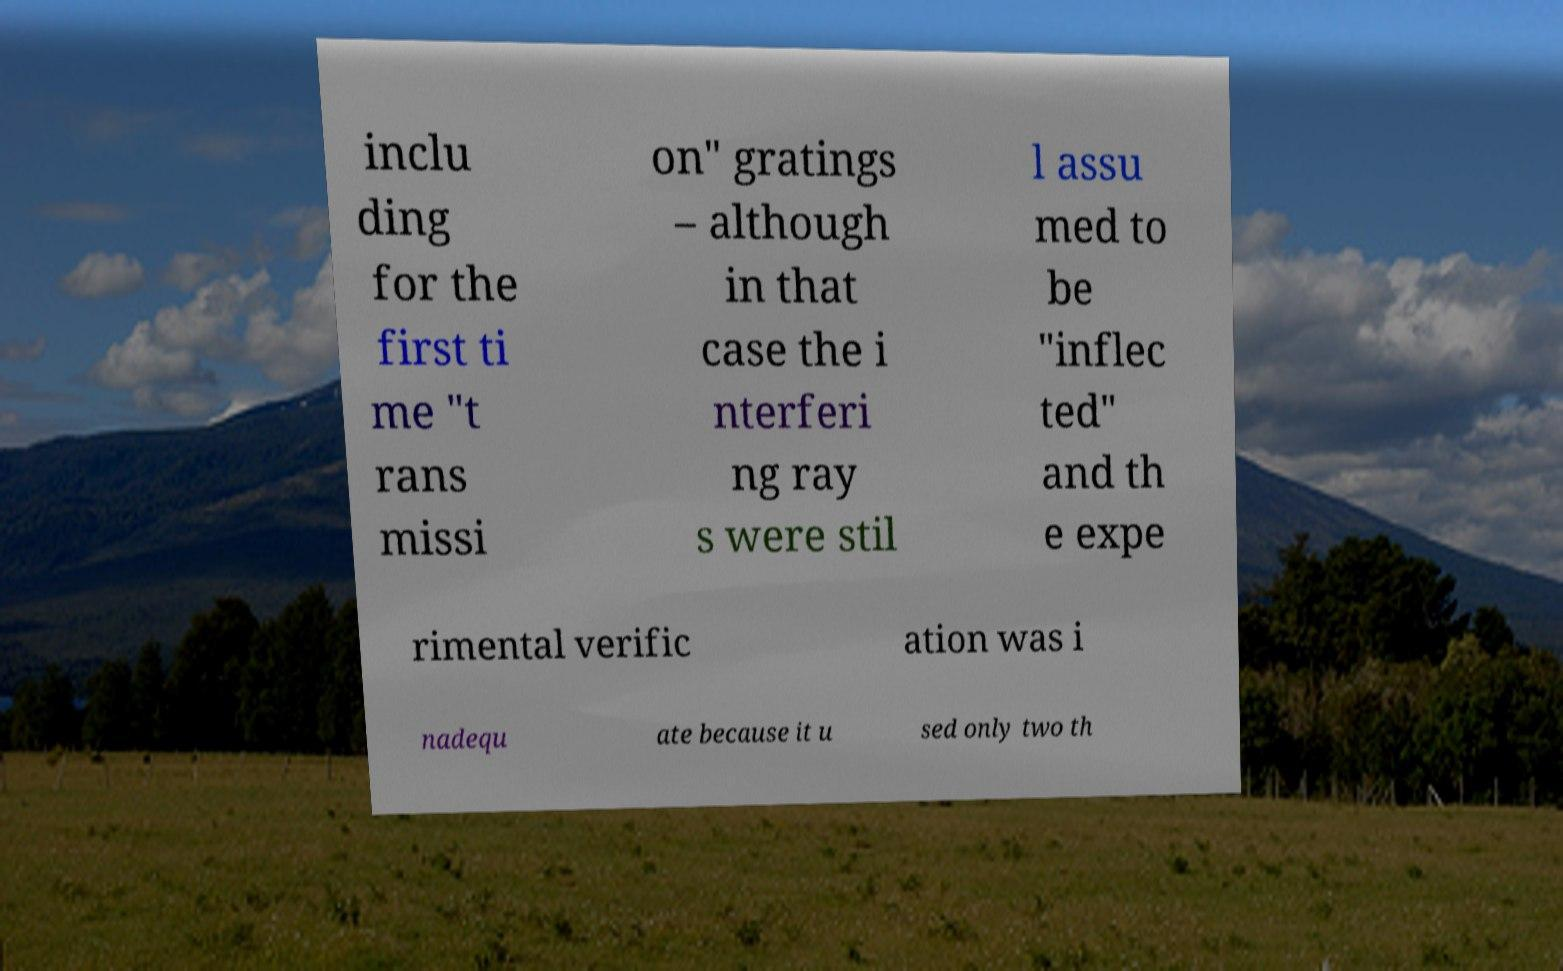I need the written content from this picture converted into text. Can you do that? inclu ding for the first ti me "t rans missi on" gratings – although in that case the i nterferi ng ray s were stil l assu med to be "inflec ted" and th e expe rimental verific ation was i nadequ ate because it u sed only two th 